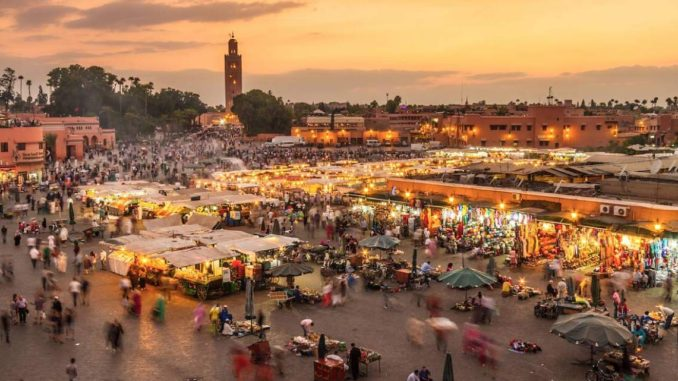If you were to capture this scene in a painting, which elements would you emphasize and why? If capturing this scene in a painting, I would emphasize several key elements to convey the essence of Jemaa El Fnaa. Firstly, the vibrant colors and the interplay of light and shadows from the setting sun would be highlighted, as they create a warm and inviting atmosphere. The bustling crowd and the variety of stalls would be focal points to illustrate the market’s lively and chaotic nature. The tall silhouette of the Koutoubia Mosque in the background would add a sense of place and historical significance. Including details like the blur of people’s movements and the intricate designs of the market stalls would add depth and richness, encapsulating the dynamic and spirited essence of the marketplace. Imagine if the marketplace came alive at night and the stalls transformed into something mystical. What would you envision? As night falls and the marketplace transforms into a mystical realm, the stalls would light up with magical, ethereal glows, casting multi-colored lights all around. The vendors would transform into enigmatic figures, akin to wizards and enchantresses, offering not just goods but enchanted items and secrets from ancient lore. The aromas would shift, blending exotic scents of rare herbs and enchanting potions. The air would hum with a soft, mystical music seemingly coming from nowhere yet everywhere. Creatures of folklore, perhaps sprites or mystical animals, might dart about playfully, adding to the sense of wonder. The Koutoubia Mosque’s minaret could shine with a moonlit glow, emitting a serene, otherworldly aura that watches over the enchanted marketplace. 